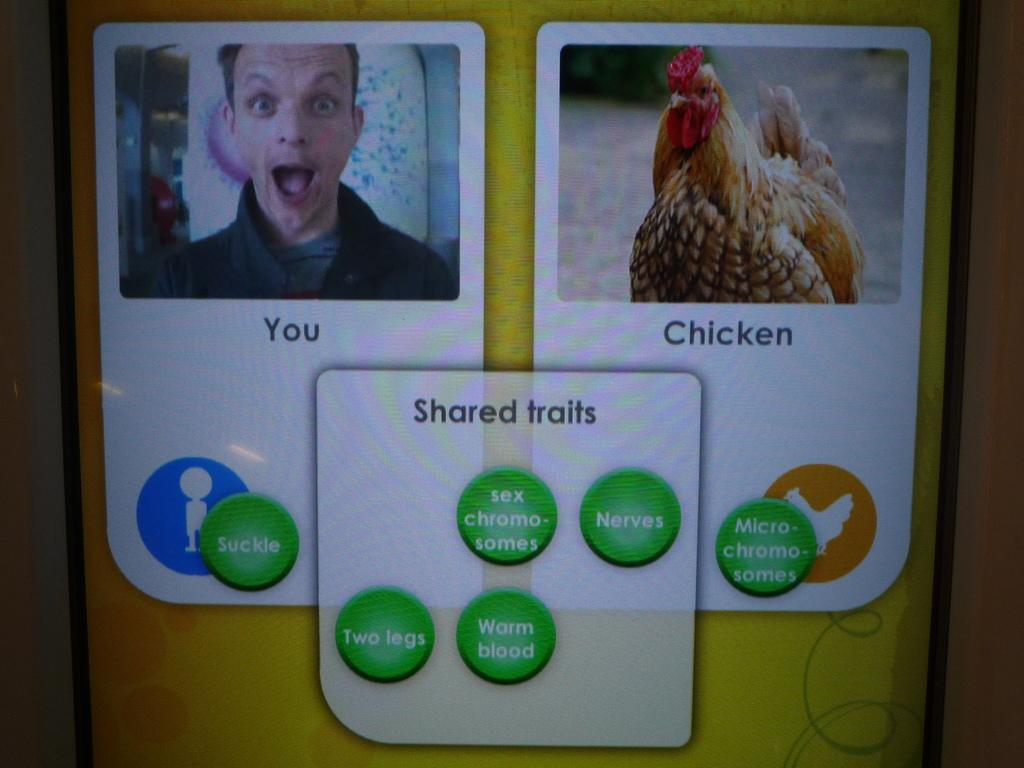What is the main object in the image? There is a screen in the image. What can be seen on the screen? A person's face and a bird are visible on the screen. Can you describe the bird on the screen? The bird has brown and cream colors. Is there any text or writing on the screen? Yes, there is text or writing on the screen. How many children are playing in the cave in the image? There is no cave or children present in the image. What color is the orange in the image? There is no orange present in the image. 